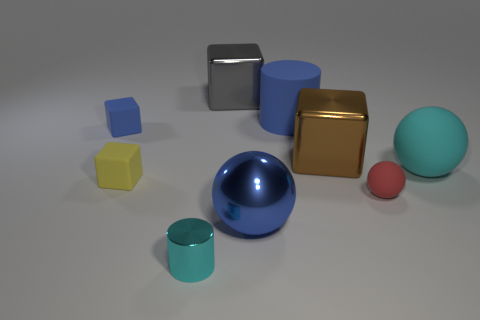Add 1 cylinders. How many objects exist? 10 Subtract all cylinders. How many objects are left? 7 Subtract 0 purple spheres. How many objects are left? 9 Subtract all blue rubber balls. Subtract all small red things. How many objects are left? 8 Add 1 big cyan spheres. How many big cyan spheres are left? 2 Add 2 small shiny spheres. How many small shiny spheres exist? 2 